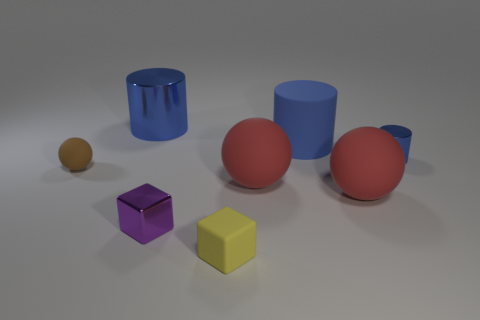Can you describe the colors of the objects in the image? Certainly! In the image, there are objects in various colors: a brown small sphere, a red sphere, a blue cylinder, a light blue cylinder, a purple cube, and a yellow cube. 